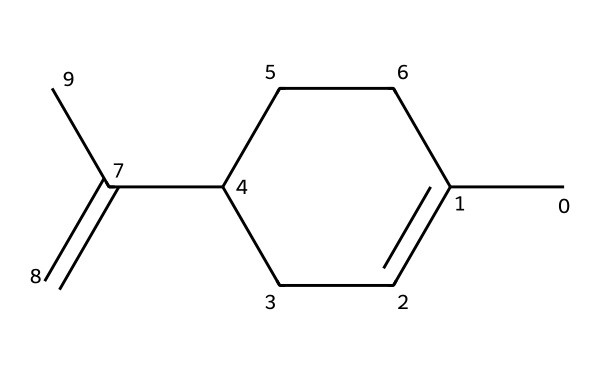What is the molecular formula of limonene? To determine the molecular formula, count the number of carbon (C) and hydrogen (H) atoms from the SMILES representation. The structure shows 10 carbon atoms and 16 hydrogen atoms. Thus, the molecular formula is C10H16.
Answer: C10H16 How many rings are present in limonene? The SMILES representation indicates that there is a cycloalkane portion due to the presence of cyclic connections. By observing the structure, there is one ring, which is a part of the cyclohexene structure.
Answer: 1 What type of chemical is limonene classified as? Limonene is a naturally occurring compound characterized as a terpene due to its structure and biological origin. This classification is evident from its hydrocarbon structure, typical of terpenes.
Answer: terpene What functional group is prevalent in limonene? In analyzing the structure, it appears that limonene has a double bond (C=C) indicated in its SMILES representation. This double bond functions as an alkene functional group within the terpene structure.
Answer: alkene How many hydrogen atoms are attached to the double-bonded carbon atoms in limonene? The structure shows that both carbon atoms involved in the double bond can have only one hydrogen atom each due to tetravalency rules. Counting the hydrogen atoms on those double-bonded carbons gives us 2 hydrogen atoms.
Answer: 2 Is limonene acyclic or cyclic? The presence of a ring structure in the compound categorizes limonene as cyclic. Observing the attachment points in the SMILES, we see a closed loop which confirms this classification.
Answer: cyclic 